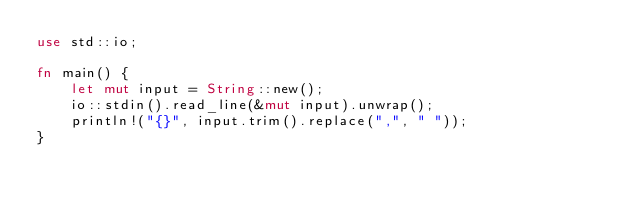<code> <loc_0><loc_0><loc_500><loc_500><_Rust_>use std::io;

fn main() {
    let mut input = String::new();
    io::stdin().read_line(&mut input).unwrap();
    println!("{}", input.trim().replace(",", " "));
}

</code> 